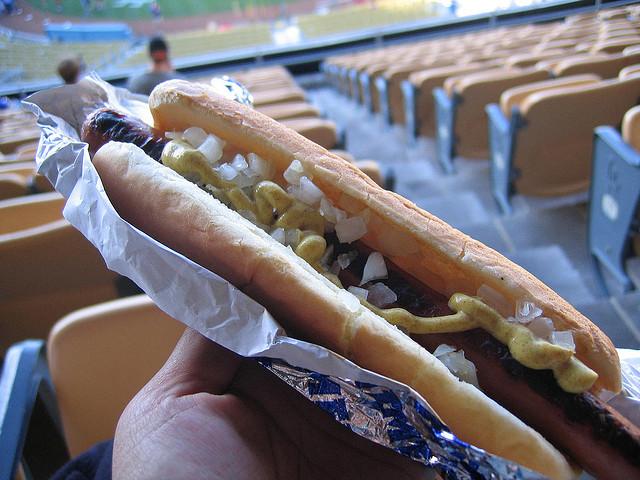How much does this hotdog cost?
Be succinct. 2.50. Is the hot dog longer than the bun?
Short answer required. Yes. Is there mustard on the hot dog?
Quick response, please. Yes. 